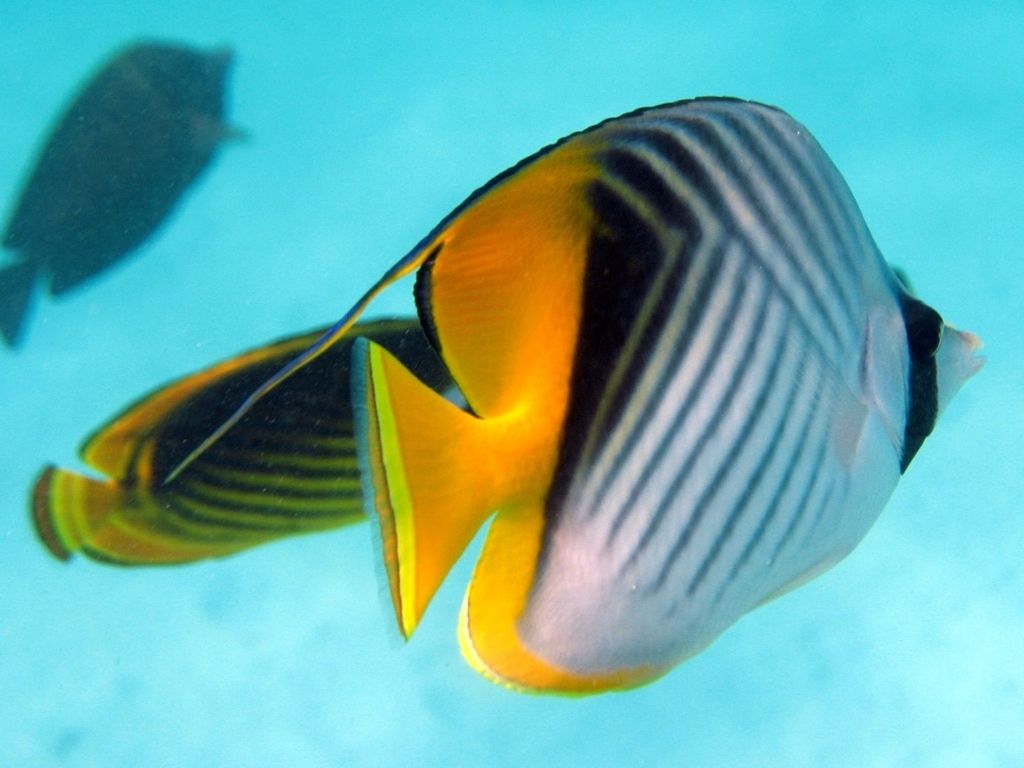What can you tell me about the species of this tropical fish? This tropical fish, with its distinct yellow, black, and white banding, resembles the Butterflyfish species, known for their vibrant colors and patterns that serve various purposes such as camouflage, warning, and mating. They are primarily found in warm ocean waters, such as the Atlantic, Indian, and Pacific oceans, and have a diet that often includes coral polyps, making them an integral part of the coral reef ecosystem. 